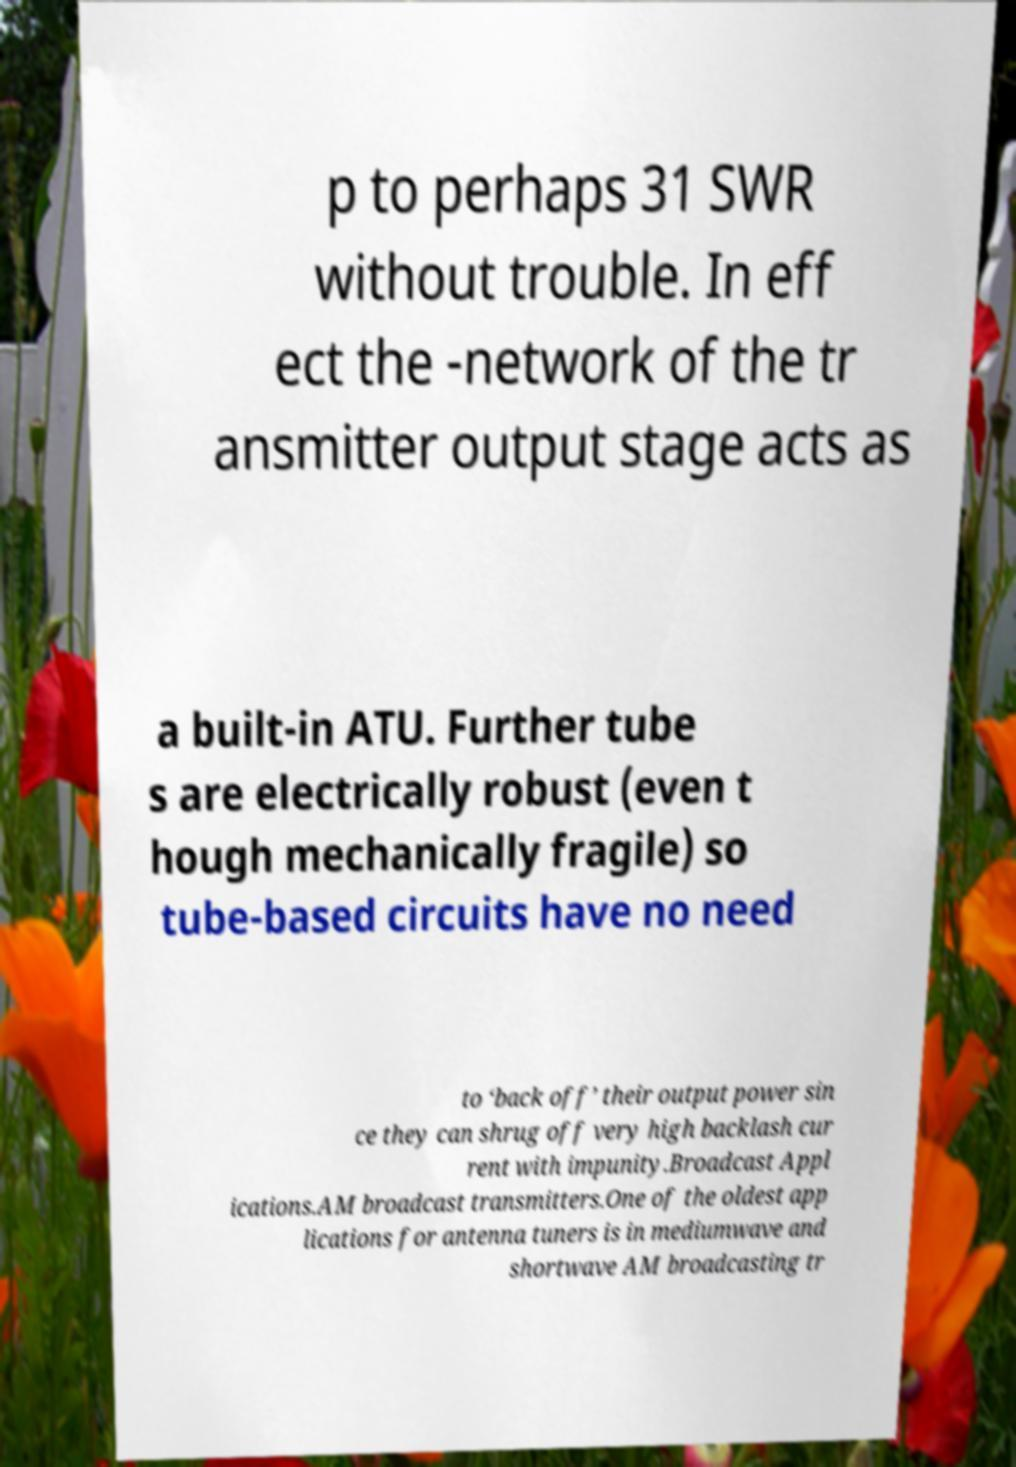What messages or text are displayed in this image? I need them in a readable, typed format. p to perhaps 31 SWR without trouble. In eff ect the -network of the tr ansmitter output stage acts as a built-in ATU. Further tube s are electrically robust (even t hough mechanically fragile) so tube-based circuits have no need to ‘back off’ their output power sin ce they can shrug off very high backlash cur rent with impunity.Broadcast Appl ications.AM broadcast transmitters.One of the oldest app lications for antenna tuners is in mediumwave and shortwave AM broadcasting tr 